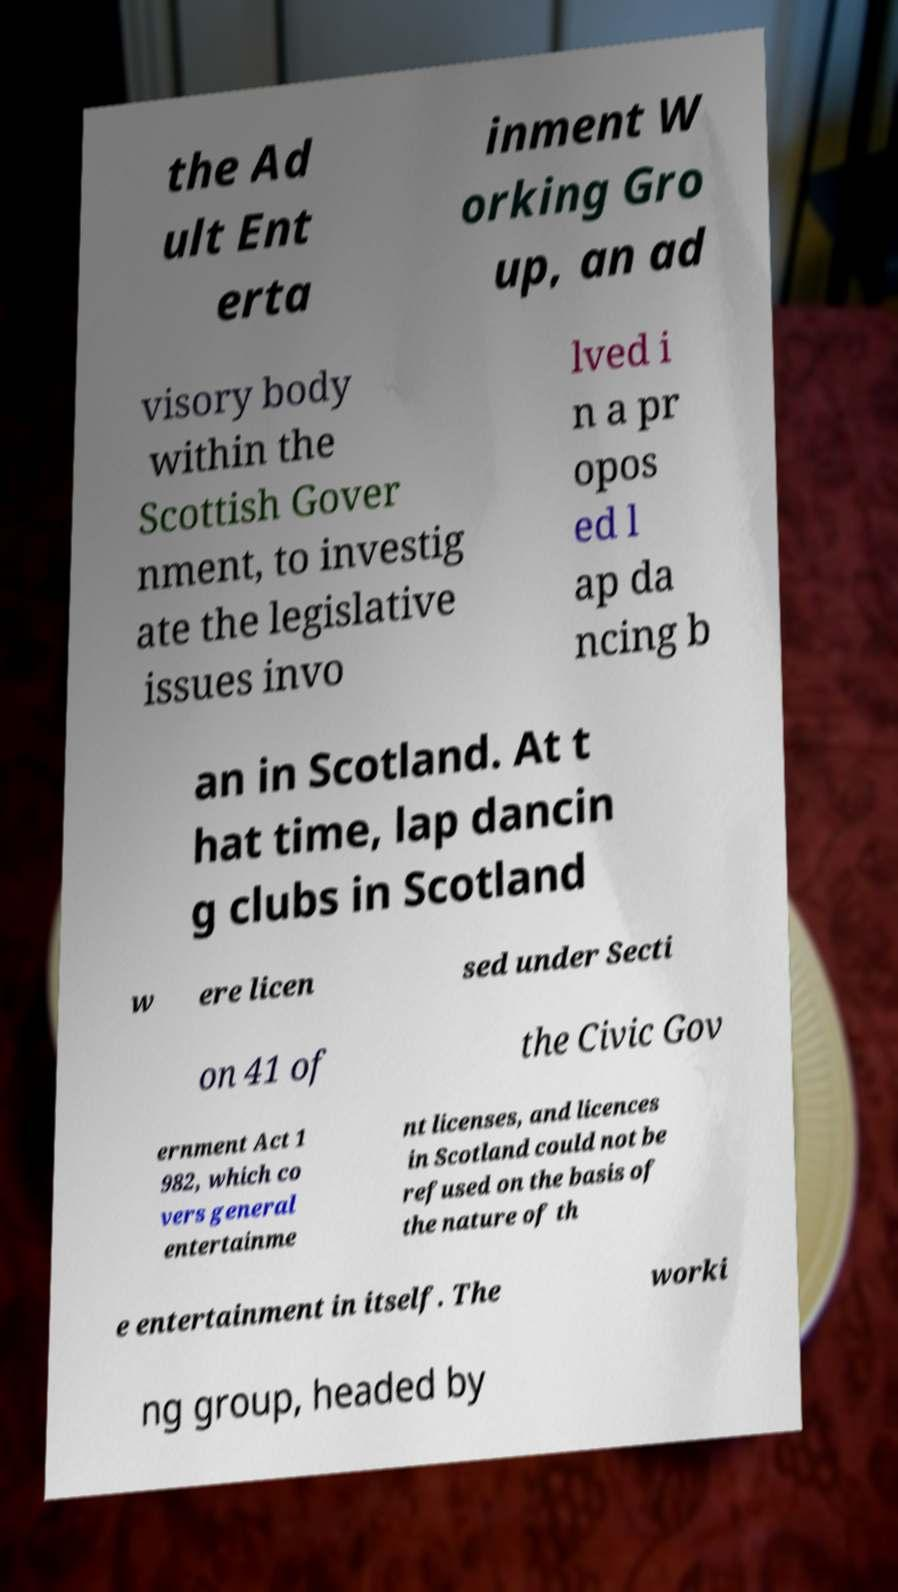Could you extract and type out the text from this image? the Ad ult Ent erta inment W orking Gro up, an ad visory body within the Scottish Gover nment, to investig ate the legislative issues invo lved i n a pr opos ed l ap da ncing b an in Scotland. At t hat time, lap dancin g clubs in Scotland w ere licen sed under Secti on 41 of the Civic Gov ernment Act 1 982, which co vers general entertainme nt licenses, and licences in Scotland could not be refused on the basis of the nature of th e entertainment in itself. The worki ng group, headed by 